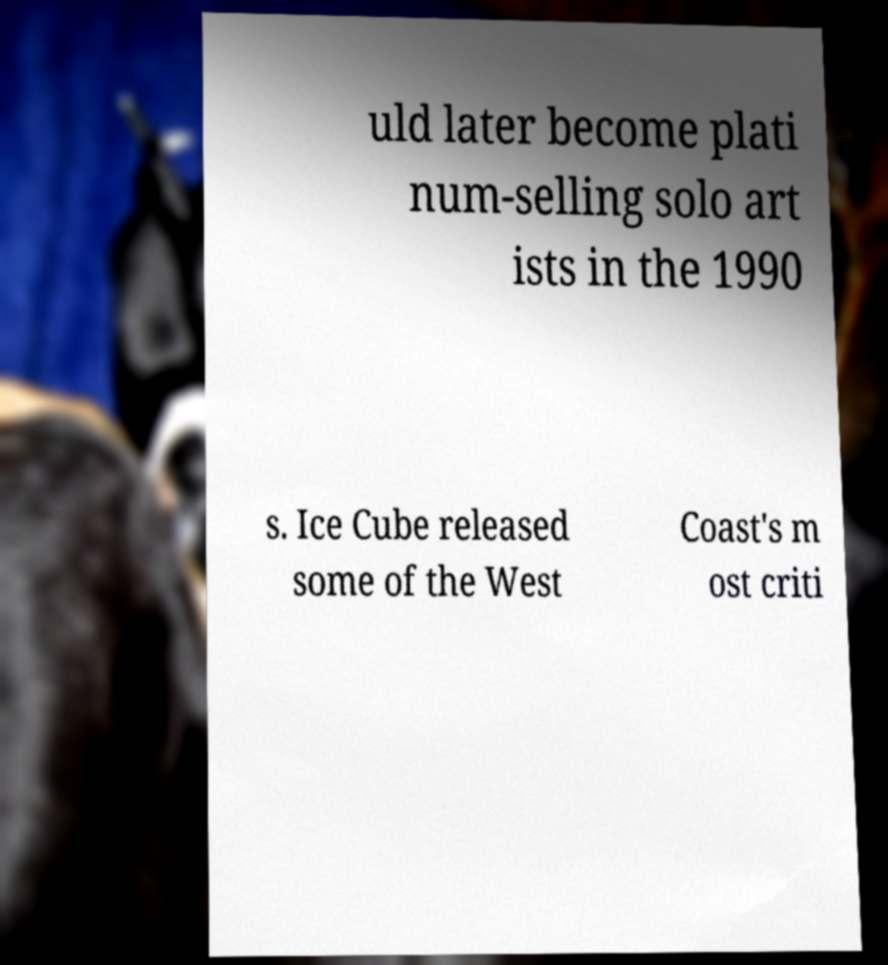Could you assist in decoding the text presented in this image and type it out clearly? uld later become plati num-selling solo art ists in the 1990 s. Ice Cube released some of the West Coast's m ost criti 